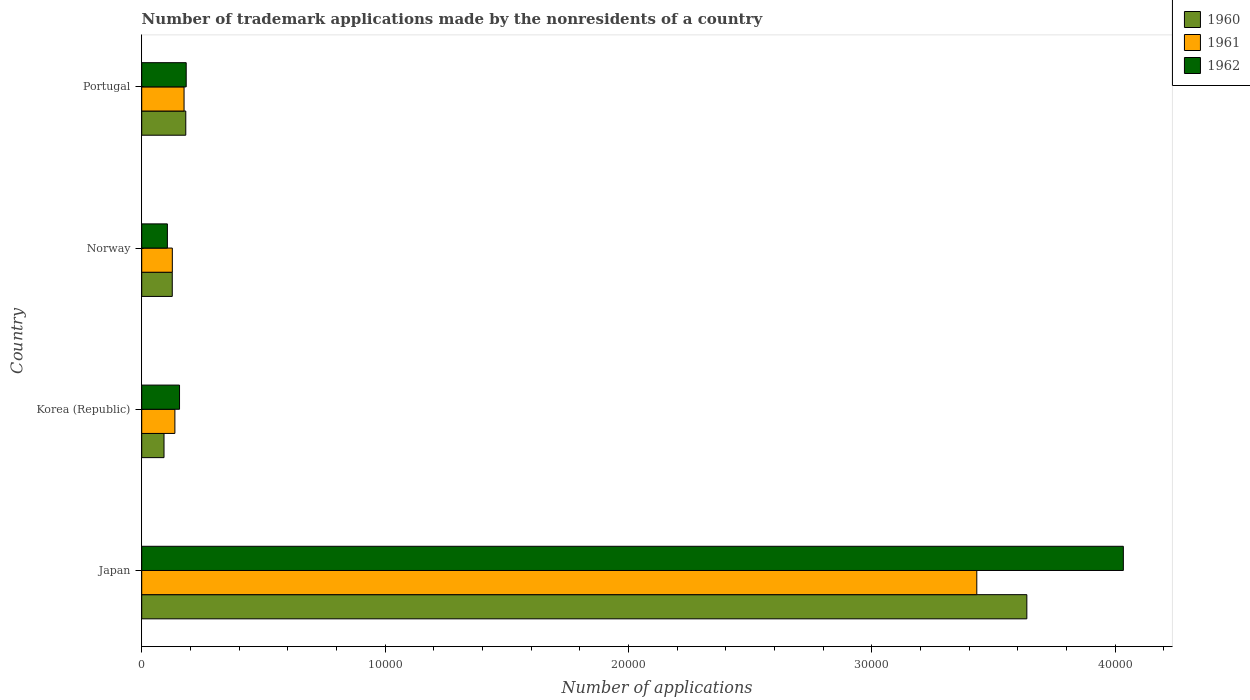How many groups of bars are there?
Your answer should be compact. 4. How many bars are there on the 4th tick from the top?
Ensure brevity in your answer.  3. How many bars are there on the 1st tick from the bottom?
Your response must be concise. 3. What is the label of the 1st group of bars from the top?
Your response must be concise. Portugal. In how many cases, is the number of bars for a given country not equal to the number of legend labels?
Make the answer very short. 0. What is the number of trademark applications made by the nonresidents in 1961 in Japan?
Your response must be concise. 3.43e+04. Across all countries, what is the maximum number of trademark applications made by the nonresidents in 1962?
Your answer should be very brief. 4.03e+04. Across all countries, what is the minimum number of trademark applications made by the nonresidents in 1960?
Your response must be concise. 916. What is the total number of trademark applications made by the nonresidents in 1962 in the graph?
Provide a short and direct response. 4.48e+04. What is the difference between the number of trademark applications made by the nonresidents in 1962 in Norway and that in Portugal?
Keep it short and to the point. -773. What is the difference between the number of trademark applications made by the nonresidents in 1960 in Japan and the number of trademark applications made by the nonresidents in 1961 in Portugal?
Provide a succinct answer. 3.46e+04. What is the average number of trademark applications made by the nonresidents in 1962 per country?
Make the answer very short. 1.12e+04. What is the ratio of the number of trademark applications made by the nonresidents in 1960 in Japan to that in Korea (Republic)?
Your answer should be compact. 39.71. Is the number of trademark applications made by the nonresidents in 1960 in Japan less than that in Korea (Republic)?
Provide a succinct answer. No. Is the difference between the number of trademark applications made by the nonresidents in 1962 in Japan and Korea (Republic) greater than the difference between the number of trademark applications made by the nonresidents in 1961 in Japan and Korea (Republic)?
Provide a short and direct response. Yes. What is the difference between the highest and the second highest number of trademark applications made by the nonresidents in 1962?
Your answer should be very brief. 3.85e+04. What is the difference between the highest and the lowest number of trademark applications made by the nonresidents in 1960?
Ensure brevity in your answer.  3.55e+04. In how many countries, is the number of trademark applications made by the nonresidents in 1961 greater than the average number of trademark applications made by the nonresidents in 1961 taken over all countries?
Your answer should be compact. 1. What does the 3rd bar from the bottom in Portugal represents?
Offer a terse response. 1962. How many countries are there in the graph?
Your answer should be very brief. 4. What is the difference between two consecutive major ticks on the X-axis?
Provide a succinct answer. 10000. Are the values on the major ticks of X-axis written in scientific E-notation?
Give a very brief answer. No. Where does the legend appear in the graph?
Offer a very short reply. Top right. What is the title of the graph?
Your answer should be compact. Number of trademark applications made by the nonresidents of a country. Does "1974" appear as one of the legend labels in the graph?
Provide a short and direct response. No. What is the label or title of the X-axis?
Offer a terse response. Number of applications. What is the Number of applications of 1960 in Japan?
Keep it short and to the point. 3.64e+04. What is the Number of applications of 1961 in Japan?
Provide a short and direct response. 3.43e+04. What is the Number of applications of 1962 in Japan?
Your answer should be very brief. 4.03e+04. What is the Number of applications in 1960 in Korea (Republic)?
Provide a succinct answer. 916. What is the Number of applications of 1961 in Korea (Republic)?
Provide a short and direct response. 1363. What is the Number of applications in 1962 in Korea (Republic)?
Your answer should be very brief. 1554. What is the Number of applications in 1960 in Norway?
Provide a succinct answer. 1255. What is the Number of applications in 1961 in Norway?
Offer a terse response. 1258. What is the Number of applications in 1962 in Norway?
Make the answer very short. 1055. What is the Number of applications of 1960 in Portugal?
Ensure brevity in your answer.  1811. What is the Number of applications of 1961 in Portugal?
Make the answer very short. 1740. What is the Number of applications in 1962 in Portugal?
Your response must be concise. 1828. Across all countries, what is the maximum Number of applications of 1960?
Your answer should be compact. 3.64e+04. Across all countries, what is the maximum Number of applications in 1961?
Your answer should be compact. 3.43e+04. Across all countries, what is the maximum Number of applications in 1962?
Make the answer very short. 4.03e+04. Across all countries, what is the minimum Number of applications of 1960?
Offer a terse response. 916. Across all countries, what is the minimum Number of applications in 1961?
Provide a short and direct response. 1258. Across all countries, what is the minimum Number of applications of 1962?
Offer a very short reply. 1055. What is the total Number of applications in 1960 in the graph?
Provide a succinct answer. 4.04e+04. What is the total Number of applications in 1961 in the graph?
Ensure brevity in your answer.  3.87e+04. What is the total Number of applications of 1962 in the graph?
Your response must be concise. 4.48e+04. What is the difference between the Number of applications of 1960 in Japan and that in Korea (Republic)?
Keep it short and to the point. 3.55e+04. What is the difference between the Number of applications of 1961 in Japan and that in Korea (Republic)?
Offer a terse response. 3.30e+04. What is the difference between the Number of applications in 1962 in Japan and that in Korea (Republic)?
Make the answer very short. 3.88e+04. What is the difference between the Number of applications of 1960 in Japan and that in Norway?
Give a very brief answer. 3.51e+04. What is the difference between the Number of applications of 1961 in Japan and that in Norway?
Offer a very short reply. 3.31e+04. What is the difference between the Number of applications in 1962 in Japan and that in Norway?
Give a very brief answer. 3.93e+04. What is the difference between the Number of applications in 1960 in Japan and that in Portugal?
Your answer should be very brief. 3.46e+04. What is the difference between the Number of applications of 1961 in Japan and that in Portugal?
Your response must be concise. 3.26e+04. What is the difference between the Number of applications in 1962 in Japan and that in Portugal?
Offer a terse response. 3.85e+04. What is the difference between the Number of applications in 1960 in Korea (Republic) and that in Norway?
Your answer should be very brief. -339. What is the difference between the Number of applications of 1961 in Korea (Republic) and that in Norway?
Give a very brief answer. 105. What is the difference between the Number of applications in 1962 in Korea (Republic) and that in Norway?
Keep it short and to the point. 499. What is the difference between the Number of applications in 1960 in Korea (Republic) and that in Portugal?
Give a very brief answer. -895. What is the difference between the Number of applications of 1961 in Korea (Republic) and that in Portugal?
Offer a very short reply. -377. What is the difference between the Number of applications of 1962 in Korea (Republic) and that in Portugal?
Provide a succinct answer. -274. What is the difference between the Number of applications in 1960 in Norway and that in Portugal?
Ensure brevity in your answer.  -556. What is the difference between the Number of applications in 1961 in Norway and that in Portugal?
Offer a terse response. -482. What is the difference between the Number of applications of 1962 in Norway and that in Portugal?
Give a very brief answer. -773. What is the difference between the Number of applications in 1960 in Japan and the Number of applications in 1961 in Korea (Republic)?
Offer a very short reply. 3.50e+04. What is the difference between the Number of applications in 1960 in Japan and the Number of applications in 1962 in Korea (Republic)?
Your answer should be very brief. 3.48e+04. What is the difference between the Number of applications of 1961 in Japan and the Number of applications of 1962 in Korea (Republic)?
Ensure brevity in your answer.  3.28e+04. What is the difference between the Number of applications of 1960 in Japan and the Number of applications of 1961 in Norway?
Provide a succinct answer. 3.51e+04. What is the difference between the Number of applications of 1960 in Japan and the Number of applications of 1962 in Norway?
Offer a terse response. 3.53e+04. What is the difference between the Number of applications in 1961 in Japan and the Number of applications in 1962 in Norway?
Provide a succinct answer. 3.33e+04. What is the difference between the Number of applications in 1960 in Japan and the Number of applications in 1961 in Portugal?
Your response must be concise. 3.46e+04. What is the difference between the Number of applications of 1960 in Japan and the Number of applications of 1962 in Portugal?
Provide a short and direct response. 3.45e+04. What is the difference between the Number of applications of 1961 in Japan and the Number of applications of 1962 in Portugal?
Your response must be concise. 3.25e+04. What is the difference between the Number of applications in 1960 in Korea (Republic) and the Number of applications in 1961 in Norway?
Give a very brief answer. -342. What is the difference between the Number of applications in 1960 in Korea (Republic) and the Number of applications in 1962 in Norway?
Make the answer very short. -139. What is the difference between the Number of applications of 1961 in Korea (Republic) and the Number of applications of 1962 in Norway?
Give a very brief answer. 308. What is the difference between the Number of applications in 1960 in Korea (Republic) and the Number of applications in 1961 in Portugal?
Make the answer very short. -824. What is the difference between the Number of applications of 1960 in Korea (Republic) and the Number of applications of 1962 in Portugal?
Offer a terse response. -912. What is the difference between the Number of applications of 1961 in Korea (Republic) and the Number of applications of 1962 in Portugal?
Your answer should be very brief. -465. What is the difference between the Number of applications of 1960 in Norway and the Number of applications of 1961 in Portugal?
Your answer should be compact. -485. What is the difference between the Number of applications of 1960 in Norway and the Number of applications of 1962 in Portugal?
Make the answer very short. -573. What is the difference between the Number of applications in 1961 in Norway and the Number of applications in 1962 in Portugal?
Your answer should be very brief. -570. What is the average Number of applications in 1960 per country?
Offer a very short reply. 1.01e+04. What is the average Number of applications of 1961 per country?
Ensure brevity in your answer.  9670.25. What is the average Number of applications of 1962 per country?
Your answer should be compact. 1.12e+04. What is the difference between the Number of applications in 1960 and Number of applications in 1961 in Japan?
Make the answer very short. 2057. What is the difference between the Number of applications of 1960 and Number of applications of 1962 in Japan?
Make the answer very short. -3966. What is the difference between the Number of applications of 1961 and Number of applications of 1962 in Japan?
Offer a very short reply. -6023. What is the difference between the Number of applications of 1960 and Number of applications of 1961 in Korea (Republic)?
Your answer should be compact. -447. What is the difference between the Number of applications in 1960 and Number of applications in 1962 in Korea (Republic)?
Make the answer very short. -638. What is the difference between the Number of applications in 1961 and Number of applications in 1962 in Korea (Republic)?
Keep it short and to the point. -191. What is the difference between the Number of applications in 1960 and Number of applications in 1961 in Norway?
Make the answer very short. -3. What is the difference between the Number of applications in 1960 and Number of applications in 1962 in Norway?
Make the answer very short. 200. What is the difference between the Number of applications of 1961 and Number of applications of 1962 in Norway?
Provide a short and direct response. 203. What is the difference between the Number of applications of 1960 and Number of applications of 1961 in Portugal?
Offer a terse response. 71. What is the difference between the Number of applications in 1960 and Number of applications in 1962 in Portugal?
Your answer should be very brief. -17. What is the difference between the Number of applications of 1961 and Number of applications of 1962 in Portugal?
Keep it short and to the point. -88. What is the ratio of the Number of applications of 1960 in Japan to that in Korea (Republic)?
Make the answer very short. 39.71. What is the ratio of the Number of applications in 1961 in Japan to that in Korea (Republic)?
Offer a very short reply. 25.18. What is the ratio of the Number of applications of 1962 in Japan to that in Korea (Republic)?
Keep it short and to the point. 25.96. What is the ratio of the Number of applications in 1960 in Japan to that in Norway?
Make the answer very short. 28.99. What is the ratio of the Number of applications of 1961 in Japan to that in Norway?
Provide a short and direct response. 27.28. What is the ratio of the Number of applications in 1962 in Japan to that in Norway?
Offer a very short reply. 38.24. What is the ratio of the Number of applications in 1960 in Japan to that in Portugal?
Your response must be concise. 20.09. What is the ratio of the Number of applications in 1961 in Japan to that in Portugal?
Your response must be concise. 19.72. What is the ratio of the Number of applications of 1962 in Japan to that in Portugal?
Give a very brief answer. 22.07. What is the ratio of the Number of applications of 1960 in Korea (Republic) to that in Norway?
Ensure brevity in your answer.  0.73. What is the ratio of the Number of applications of 1961 in Korea (Republic) to that in Norway?
Keep it short and to the point. 1.08. What is the ratio of the Number of applications in 1962 in Korea (Republic) to that in Norway?
Make the answer very short. 1.47. What is the ratio of the Number of applications in 1960 in Korea (Republic) to that in Portugal?
Ensure brevity in your answer.  0.51. What is the ratio of the Number of applications in 1961 in Korea (Republic) to that in Portugal?
Offer a terse response. 0.78. What is the ratio of the Number of applications in 1962 in Korea (Republic) to that in Portugal?
Your response must be concise. 0.85. What is the ratio of the Number of applications in 1960 in Norway to that in Portugal?
Make the answer very short. 0.69. What is the ratio of the Number of applications in 1961 in Norway to that in Portugal?
Keep it short and to the point. 0.72. What is the ratio of the Number of applications in 1962 in Norway to that in Portugal?
Make the answer very short. 0.58. What is the difference between the highest and the second highest Number of applications in 1960?
Keep it short and to the point. 3.46e+04. What is the difference between the highest and the second highest Number of applications in 1961?
Provide a succinct answer. 3.26e+04. What is the difference between the highest and the second highest Number of applications in 1962?
Make the answer very short. 3.85e+04. What is the difference between the highest and the lowest Number of applications in 1960?
Ensure brevity in your answer.  3.55e+04. What is the difference between the highest and the lowest Number of applications of 1961?
Provide a short and direct response. 3.31e+04. What is the difference between the highest and the lowest Number of applications of 1962?
Your answer should be very brief. 3.93e+04. 